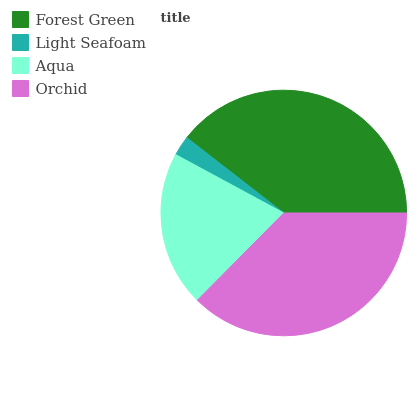Is Light Seafoam the minimum?
Answer yes or no. Yes. Is Forest Green the maximum?
Answer yes or no. Yes. Is Aqua the minimum?
Answer yes or no. No. Is Aqua the maximum?
Answer yes or no. No. Is Aqua greater than Light Seafoam?
Answer yes or no. Yes. Is Light Seafoam less than Aqua?
Answer yes or no. Yes. Is Light Seafoam greater than Aqua?
Answer yes or no. No. Is Aqua less than Light Seafoam?
Answer yes or no. No. Is Orchid the high median?
Answer yes or no. Yes. Is Aqua the low median?
Answer yes or no. Yes. Is Forest Green the high median?
Answer yes or no. No. Is Forest Green the low median?
Answer yes or no. No. 